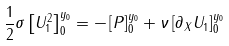<formula> <loc_0><loc_0><loc_500><loc_500>\frac { 1 } { 2 } \sigma \left [ U _ { 1 } ^ { 2 } \right ] _ { 0 } ^ { y _ { 0 } } = - \left [ P \right ] _ { 0 } ^ { y _ { 0 } } + \nu \left [ \partial _ { X } U _ { 1 } \right ] _ { 0 } ^ { y _ { 0 } }</formula> 